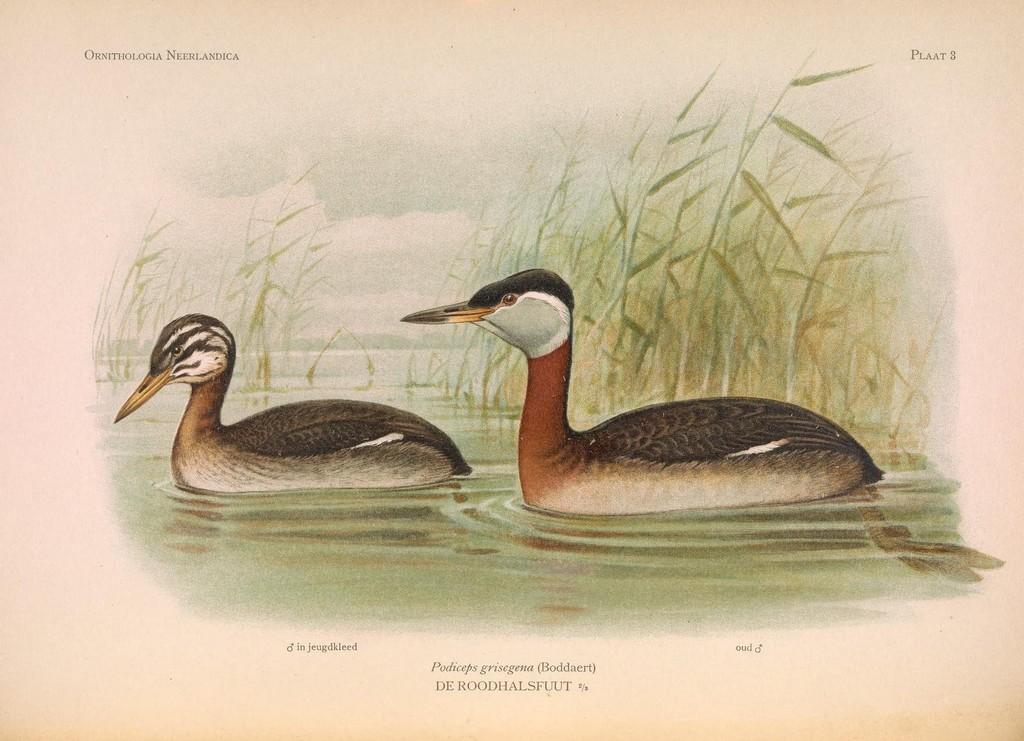Describe this image in one or two sentences. This picture is a drawing, in this picture there are two ducks in water, in the background there is grass. 